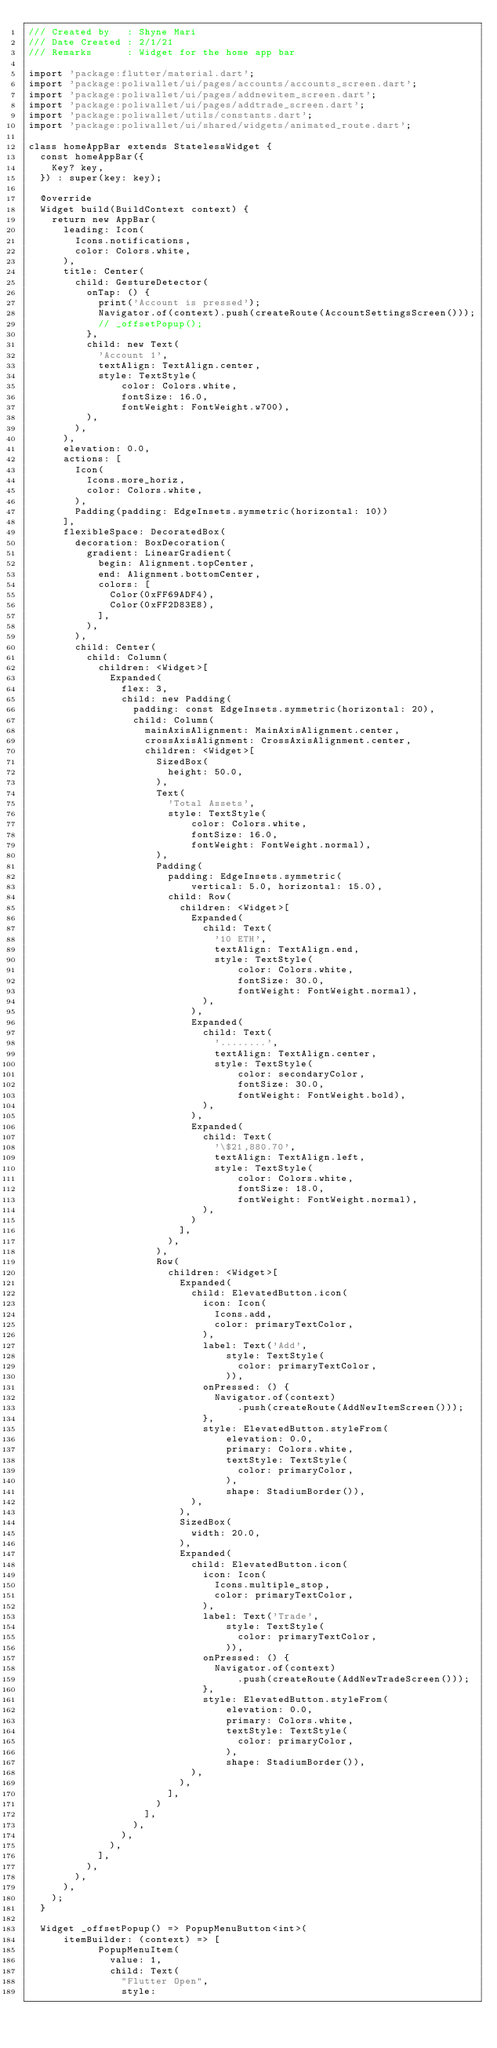Convert code to text. <code><loc_0><loc_0><loc_500><loc_500><_Dart_>/// Created by   : Shyne Mari
/// Date Created : 2/1/21
/// Remarks      : Widget for the home app bar

import 'package:flutter/material.dart';
import 'package:poliwallet/ui/pages/accounts/accounts_screen.dart';
import 'package:poliwallet/ui/pages/addnewitem_screen.dart';
import 'package:poliwallet/ui/pages/addtrade_screen.dart';
import 'package:poliwallet/utils/constants.dart';
import 'package:poliwallet/ui/shared/widgets/animated_route.dart';

class homeAppBar extends StatelessWidget {
  const homeAppBar({
    Key? key,
  }) : super(key: key);

  @override
  Widget build(BuildContext context) {
    return new AppBar(
      leading: Icon(
        Icons.notifications,
        color: Colors.white,
      ),
      title: Center(
        child: GestureDetector(
          onTap: () {
            print('Account is pressed');
            Navigator.of(context).push(createRoute(AccountSettingsScreen()));
            // _offsetPopup();
          },
          child: new Text(
            'Account 1',
            textAlign: TextAlign.center,
            style: TextStyle(
                color: Colors.white,
                fontSize: 16.0,
                fontWeight: FontWeight.w700),
          ),
        ),
      ),
      elevation: 0.0,
      actions: [
        Icon(
          Icons.more_horiz,
          color: Colors.white,
        ),
        Padding(padding: EdgeInsets.symmetric(horizontal: 10))
      ],
      flexibleSpace: DecoratedBox(
        decoration: BoxDecoration(
          gradient: LinearGradient(
            begin: Alignment.topCenter,
            end: Alignment.bottomCenter,
            colors: [
              Color(0xFF69ADF4),
              Color(0xFF2D83E8),
            ],
          ),
        ),
        child: Center(
          child: Column(
            children: <Widget>[
              Expanded(
                flex: 3,
                child: new Padding(
                  padding: const EdgeInsets.symmetric(horizontal: 20),
                  child: Column(
                    mainAxisAlignment: MainAxisAlignment.center,
                    crossAxisAlignment: CrossAxisAlignment.center,
                    children: <Widget>[
                      SizedBox(
                        height: 50.0,
                      ),
                      Text(
                        'Total Assets',
                        style: TextStyle(
                            color: Colors.white,
                            fontSize: 16.0,
                            fontWeight: FontWeight.normal),
                      ),
                      Padding(
                        padding: EdgeInsets.symmetric(
                            vertical: 5.0, horizontal: 15.0),
                        child: Row(
                          children: <Widget>[
                            Expanded(
                              child: Text(
                                '10 ETH',
                                textAlign: TextAlign.end,
                                style: TextStyle(
                                    color: Colors.white,
                                    fontSize: 30.0,
                                    fontWeight: FontWeight.normal),
                              ),
                            ),
                            Expanded(
                              child: Text(
                                '........',
                                textAlign: TextAlign.center,
                                style: TextStyle(
                                    color: secondaryColor,
                                    fontSize: 30.0,
                                    fontWeight: FontWeight.bold),
                              ),
                            ),
                            Expanded(
                              child: Text(
                                '\$21,880.70',
                                textAlign: TextAlign.left,
                                style: TextStyle(
                                    color: Colors.white,
                                    fontSize: 18.0,
                                    fontWeight: FontWeight.normal),
                              ),
                            )
                          ],
                        ),
                      ),
                      Row(
                        children: <Widget>[
                          Expanded(
                            child: ElevatedButton.icon(
                              icon: Icon(
                                Icons.add,
                                color: primaryTextColor,
                              ),
                              label: Text('Add',
                                  style: TextStyle(
                                    color: primaryTextColor,
                                  )),
                              onPressed: () {
                                Navigator.of(context)
                                    .push(createRoute(AddNewItemScreen()));
                              },
                              style: ElevatedButton.styleFrom(
                                  elevation: 0.0,
                                  primary: Colors.white,
                                  textStyle: TextStyle(
                                    color: primaryColor,
                                  ),
                                  shape: StadiumBorder()),
                            ),
                          ),
                          SizedBox(
                            width: 20.0,
                          ),
                          Expanded(
                            child: ElevatedButton.icon(
                              icon: Icon(
                                Icons.multiple_stop,
                                color: primaryTextColor,
                              ),
                              label: Text('Trade',
                                  style: TextStyle(
                                    color: primaryTextColor,
                                  )),
                              onPressed: () {
                                Navigator.of(context)
                                    .push(createRoute(AddNewTradeScreen()));
                              },
                              style: ElevatedButton.styleFrom(
                                  elevation: 0.0,
                                  primary: Colors.white,
                                  textStyle: TextStyle(
                                    color: primaryColor,
                                  ),
                                  shape: StadiumBorder()),
                            ),
                          ),
                        ],
                      )
                    ],
                  ),
                ),
              ),
            ],
          ),
        ),
      ),
    );
  }

  Widget _offsetPopup() => PopupMenuButton<int>(
      itemBuilder: (context) => [
            PopupMenuItem(
              value: 1,
              child: Text(
                "Flutter Open",
                style:</code> 